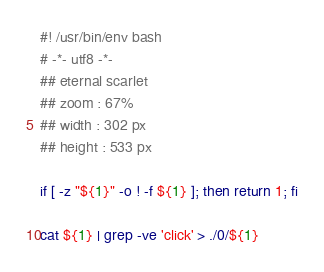Convert code to text. <code><loc_0><loc_0><loc_500><loc_500><_Bash_>#! /usr/bin/env bash
# -*- utf8 -*-
## eternal scarlet
## zoom : 67%
## width : 302 px
## height : 533 px

if [ -z "${1}" -o ! -f ${1} ]; then return 1; fi

cat ${1} | grep -ve 'click' > ./0/${1}

</code> 